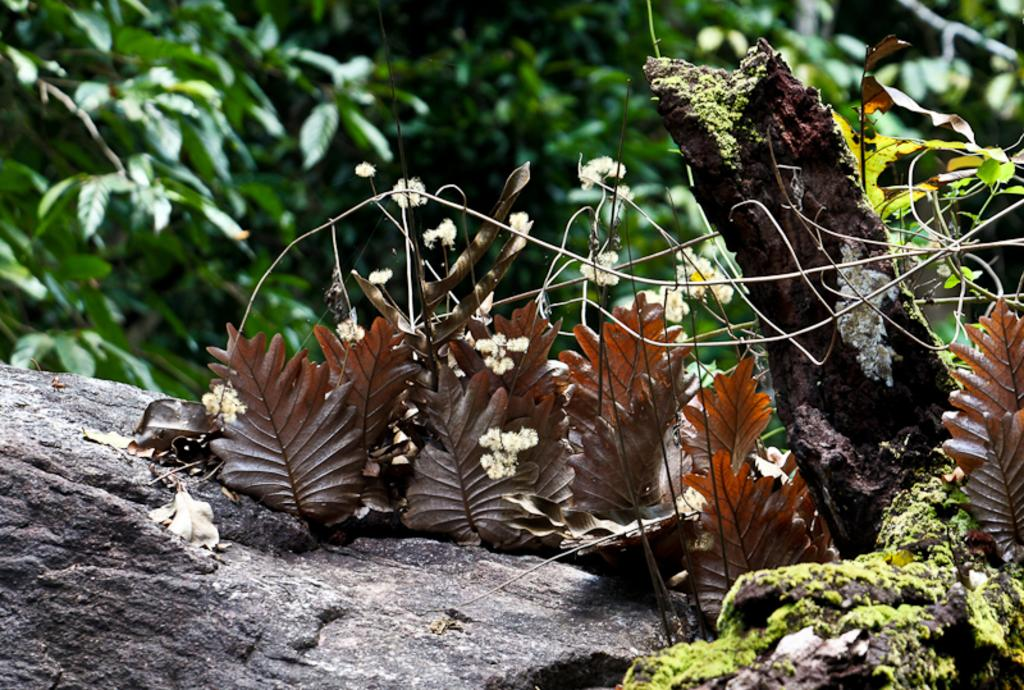What type of vegetation can be seen in the image? There are trees in the image. What is located on the rock in the image? There are dried leaves on a rock in the image. What is the bark in the image? The bark is likely from one of the trees in the image. How many bats can be seen flying in the image? There are no bats visible in the image. What is the amount of breath needed to blow the dried leaves off the rock? The image does not provide information about the amount of breath needed to blow the leaves off the rock, as it is a still image. 